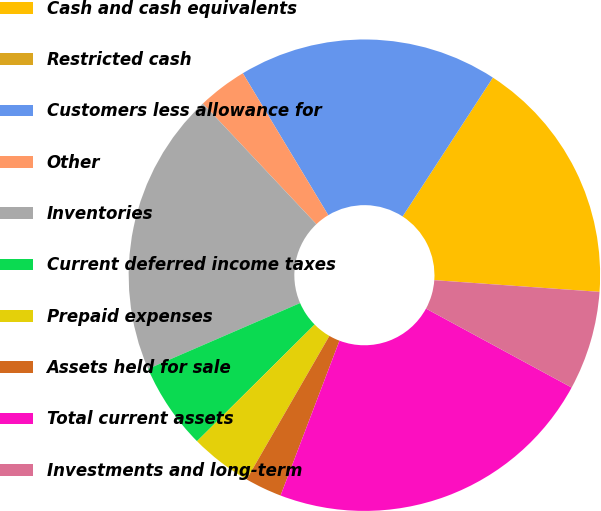Convert chart. <chart><loc_0><loc_0><loc_500><loc_500><pie_chart><fcel>Cash and cash equivalents<fcel>Restricted cash<fcel>Customers less allowance for<fcel>Other<fcel>Inventories<fcel>Current deferred income taxes<fcel>Prepaid expenses<fcel>Assets held for sale<fcel>Total current assets<fcel>Investments and long-term<nl><fcel>16.95%<fcel>0.0%<fcel>17.8%<fcel>3.39%<fcel>19.49%<fcel>5.93%<fcel>4.24%<fcel>2.54%<fcel>22.88%<fcel>6.78%<nl></chart> 